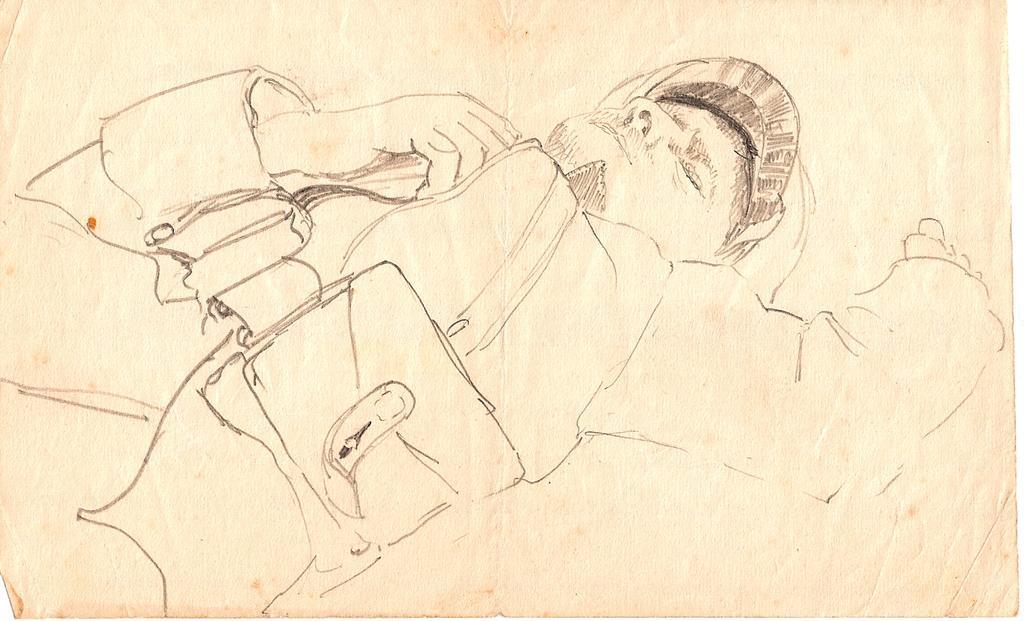In one or two sentences, can you explain what this image depicts? In this image we can see a paper. In the paper, we can see a sketch of a person. 